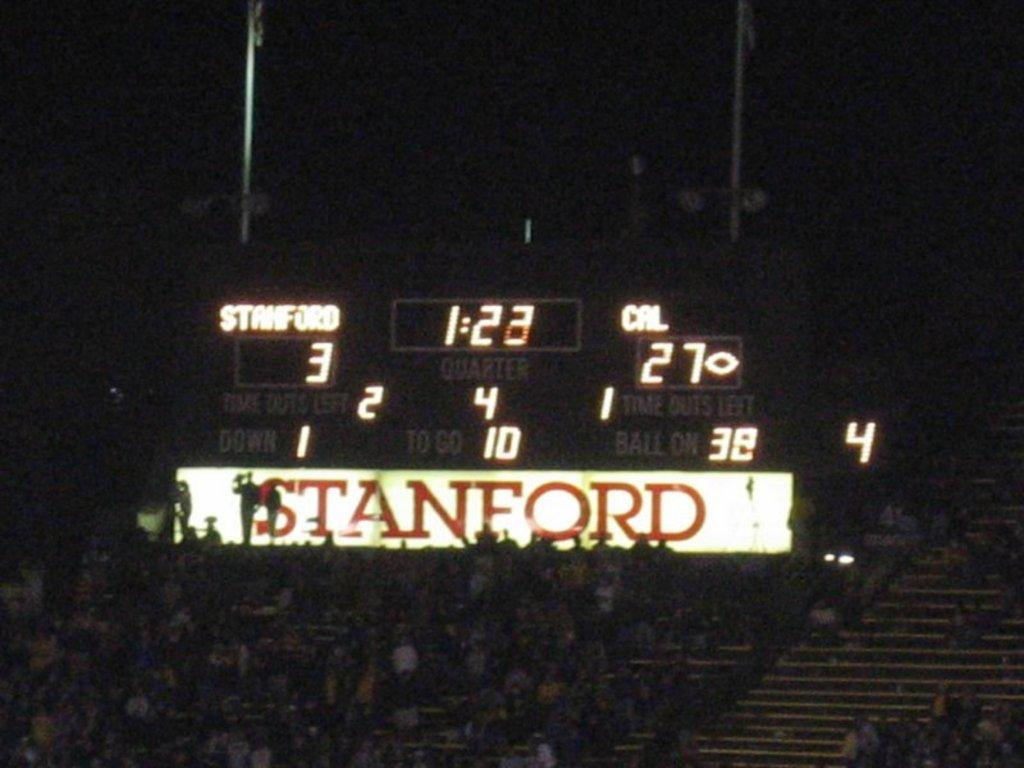<image>
Present a compact description of the photo's key features. With 1:23 left in the fourth quarter the score is Cal 27 Stanford 3 in this football game. 